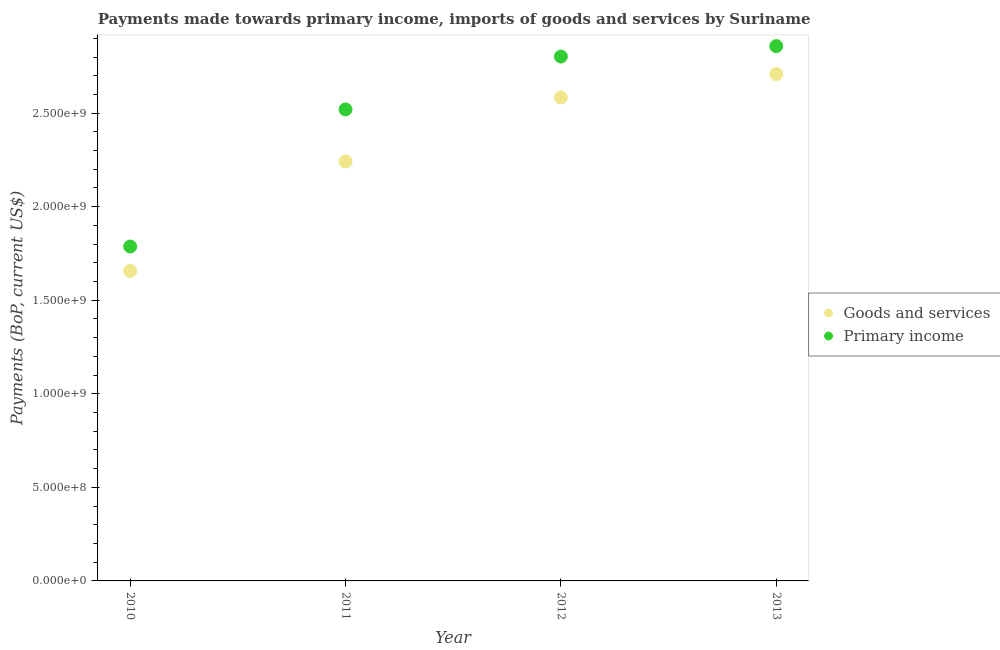Is the number of dotlines equal to the number of legend labels?
Your answer should be compact. Yes. What is the payments made towards goods and services in 2010?
Provide a short and direct response. 1.66e+09. Across all years, what is the maximum payments made towards primary income?
Offer a terse response. 2.86e+09. Across all years, what is the minimum payments made towards goods and services?
Provide a short and direct response. 1.66e+09. What is the total payments made towards goods and services in the graph?
Your answer should be very brief. 9.19e+09. What is the difference between the payments made towards goods and services in 2012 and that in 2013?
Give a very brief answer. -1.25e+08. What is the difference between the payments made towards goods and services in 2011 and the payments made towards primary income in 2013?
Keep it short and to the point. -6.17e+08. What is the average payments made towards primary income per year?
Offer a terse response. 2.49e+09. In the year 2013, what is the difference between the payments made towards goods and services and payments made towards primary income?
Make the answer very short. -1.49e+08. What is the ratio of the payments made towards goods and services in 2010 to that in 2012?
Your answer should be compact. 0.64. Is the payments made towards primary income in 2011 less than that in 2013?
Ensure brevity in your answer.  Yes. What is the difference between the highest and the second highest payments made towards goods and services?
Provide a short and direct response. 1.25e+08. What is the difference between the highest and the lowest payments made towards goods and services?
Keep it short and to the point. 1.05e+09. In how many years, is the payments made towards primary income greater than the average payments made towards primary income taken over all years?
Ensure brevity in your answer.  3. Does the payments made towards primary income monotonically increase over the years?
Keep it short and to the point. Yes. Is the payments made towards goods and services strictly greater than the payments made towards primary income over the years?
Provide a succinct answer. No. Is the payments made towards primary income strictly less than the payments made towards goods and services over the years?
Your answer should be very brief. No. What is the difference between two consecutive major ticks on the Y-axis?
Make the answer very short. 5.00e+08. Are the values on the major ticks of Y-axis written in scientific E-notation?
Make the answer very short. Yes. Does the graph contain any zero values?
Offer a very short reply. No. Does the graph contain grids?
Your answer should be compact. No. Where does the legend appear in the graph?
Your answer should be very brief. Center right. How many legend labels are there?
Offer a terse response. 2. What is the title of the graph?
Ensure brevity in your answer.  Payments made towards primary income, imports of goods and services by Suriname. What is the label or title of the Y-axis?
Provide a succinct answer. Payments (BoP, current US$). What is the Payments (BoP, current US$) in Goods and services in 2010?
Provide a succinct answer. 1.66e+09. What is the Payments (BoP, current US$) in Primary income in 2010?
Your response must be concise. 1.79e+09. What is the Payments (BoP, current US$) of Goods and services in 2011?
Provide a short and direct response. 2.24e+09. What is the Payments (BoP, current US$) of Primary income in 2011?
Offer a very short reply. 2.52e+09. What is the Payments (BoP, current US$) in Goods and services in 2012?
Your answer should be very brief. 2.58e+09. What is the Payments (BoP, current US$) of Primary income in 2012?
Your answer should be very brief. 2.80e+09. What is the Payments (BoP, current US$) of Goods and services in 2013?
Provide a succinct answer. 2.71e+09. What is the Payments (BoP, current US$) of Primary income in 2013?
Provide a succinct answer. 2.86e+09. Across all years, what is the maximum Payments (BoP, current US$) in Goods and services?
Your response must be concise. 2.71e+09. Across all years, what is the maximum Payments (BoP, current US$) in Primary income?
Your answer should be compact. 2.86e+09. Across all years, what is the minimum Payments (BoP, current US$) in Goods and services?
Your answer should be very brief. 1.66e+09. Across all years, what is the minimum Payments (BoP, current US$) of Primary income?
Your answer should be compact. 1.79e+09. What is the total Payments (BoP, current US$) of Goods and services in the graph?
Give a very brief answer. 9.19e+09. What is the total Payments (BoP, current US$) in Primary income in the graph?
Offer a terse response. 9.97e+09. What is the difference between the Payments (BoP, current US$) of Goods and services in 2010 and that in 2011?
Your response must be concise. -5.85e+08. What is the difference between the Payments (BoP, current US$) of Primary income in 2010 and that in 2011?
Ensure brevity in your answer.  -7.33e+08. What is the difference between the Payments (BoP, current US$) of Goods and services in 2010 and that in 2012?
Your response must be concise. -9.27e+08. What is the difference between the Payments (BoP, current US$) of Primary income in 2010 and that in 2012?
Keep it short and to the point. -1.02e+09. What is the difference between the Payments (BoP, current US$) in Goods and services in 2010 and that in 2013?
Your answer should be compact. -1.05e+09. What is the difference between the Payments (BoP, current US$) of Primary income in 2010 and that in 2013?
Make the answer very short. -1.07e+09. What is the difference between the Payments (BoP, current US$) in Goods and services in 2011 and that in 2012?
Provide a succinct answer. -3.42e+08. What is the difference between the Payments (BoP, current US$) of Primary income in 2011 and that in 2012?
Give a very brief answer. -2.83e+08. What is the difference between the Payments (BoP, current US$) in Goods and services in 2011 and that in 2013?
Make the answer very short. -4.68e+08. What is the difference between the Payments (BoP, current US$) of Primary income in 2011 and that in 2013?
Provide a succinct answer. -3.38e+08. What is the difference between the Payments (BoP, current US$) in Goods and services in 2012 and that in 2013?
Offer a terse response. -1.25e+08. What is the difference between the Payments (BoP, current US$) of Primary income in 2012 and that in 2013?
Provide a short and direct response. -5.58e+07. What is the difference between the Payments (BoP, current US$) of Goods and services in 2010 and the Payments (BoP, current US$) of Primary income in 2011?
Offer a terse response. -8.63e+08. What is the difference between the Payments (BoP, current US$) in Goods and services in 2010 and the Payments (BoP, current US$) in Primary income in 2012?
Offer a terse response. -1.15e+09. What is the difference between the Payments (BoP, current US$) in Goods and services in 2010 and the Payments (BoP, current US$) in Primary income in 2013?
Provide a short and direct response. -1.20e+09. What is the difference between the Payments (BoP, current US$) in Goods and services in 2011 and the Payments (BoP, current US$) in Primary income in 2012?
Provide a succinct answer. -5.61e+08. What is the difference between the Payments (BoP, current US$) of Goods and services in 2011 and the Payments (BoP, current US$) of Primary income in 2013?
Your response must be concise. -6.17e+08. What is the difference between the Payments (BoP, current US$) in Goods and services in 2012 and the Payments (BoP, current US$) in Primary income in 2013?
Your answer should be very brief. -2.74e+08. What is the average Payments (BoP, current US$) of Goods and services per year?
Ensure brevity in your answer.  2.30e+09. What is the average Payments (BoP, current US$) of Primary income per year?
Give a very brief answer. 2.49e+09. In the year 2010, what is the difference between the Payments (BoP, current US$) in Goods and services and Payments (BoP, current US$) in Primary income?
Offer a very short reply. -1.30e+08. In the year 2011, what is the difference between the Payments (BoP, current US$) in Goods and services and Payments (BoP, current US$) in Primary income?
Give a very brief answer. -2.78e+08. In the year 2012, what is the difference between the Payments (BoP, current US$) of Goods and services and Payments (BoP, current US$) of Primary income?
Make the answer very short. -2.19e+08. In the year 2013, what is the difference between the Payments (BoP, current US$) in Goods and services and Payments (BoP, current US$) in Primary income?
Provide a short and direct response. -1.49e+08. What is the ratio of the Payments (BoP, current US$) of Goods and services in 2010 to that in 2011?
Give a very brief answer. 0.74. What is the ratio of the Payments (BoP, current US$) in Primary income in 2010 to that in 2011?
Your answer should be compact. 0.71. What is the ratio of the Payments (BoP, current US$) in Goods and services in 2010 to that in 2012?
Offer a terse response. 0.64. What is the ratio of the Payments (BoP, current US$) in Primary income in 2010 to that in 2012?
Make the answer very short. 0.64. What is the ratio of the Payments (BoP, current US$) of Goods and services in 2010 to that in 2013?
Make the answer very short. 0.61. What is the ratio of the Payments (BoP, current US$) of Primary income in 2010 to that in 2013?
Provide a succinct answer. 0.63. What is the ratio of the Payments (BoP, current US$) of Goods and services in 2011 to that in 2012?
Provide a short and direct response. 0.87. What is the ratio of the Payments (BoP, current US$) in Primary income in 2011 to that in 2012?
Offer a very short reply. 0.9. What is the ratio of the Payments (BoP, current US$) in Goods and services in 2011 to that in 2013?
Offer a very short reply. 0.83. What is the ratio of the Payments (BoP, current US$) in Primary income in 2011 to that in 2013?
Keep it short and to the point. 0.88. What is the ratio of the Payments (BoP, current US$) of Goods and services in 2012 to that in 2013?
Your response must be concise. 0.95. What is the ratio of the Payments (BoP, current US$) in Primary income in 2012 to that in 2013?
Your answer should be compact. 0.98. What is the difference between the highest and the second highest Payments (BoP, current US$) in Goods and services?
Ensure brevity in your answer.  1.25e+08. What is the difference between the highest and the second highest Payments (BoP, current US$) in Primary income?
Your answer should be very brief. 5.58e+07. What is the difference between the highest and the lowest Payments (BoP, current US$) of Goods and services?
Ensure brevity in your answer.  1.05e+09. What is the difference between the highest and the lowest Payments (BoP, current US$) in Primary income?
Offer a terse response. 1.07e+09. 